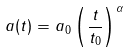<formula> <loc_0><loc_0><loc_500><loc_500>a ( t ) = a _ { 0 } \left ( \frac { t } { t _ { 0 } } \right ) ^ { \alpha }</formula> 